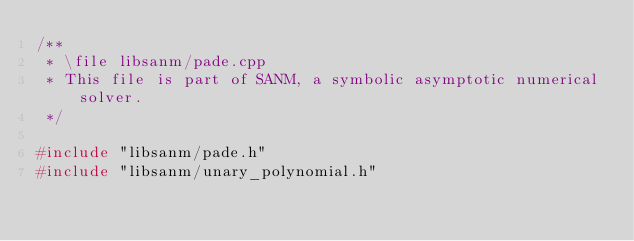Convert code to text. <code><loc_0><loc_0><loc_500><loc_500><_C++_>/**
 * \file libsanm/pade.cpp
 * This file is part of SANM, a symbolic asymptotic numerical solver.
 */

#include "libsanm/pade.h"
#include "libsanm/unary_polynomial.h"
</code> 